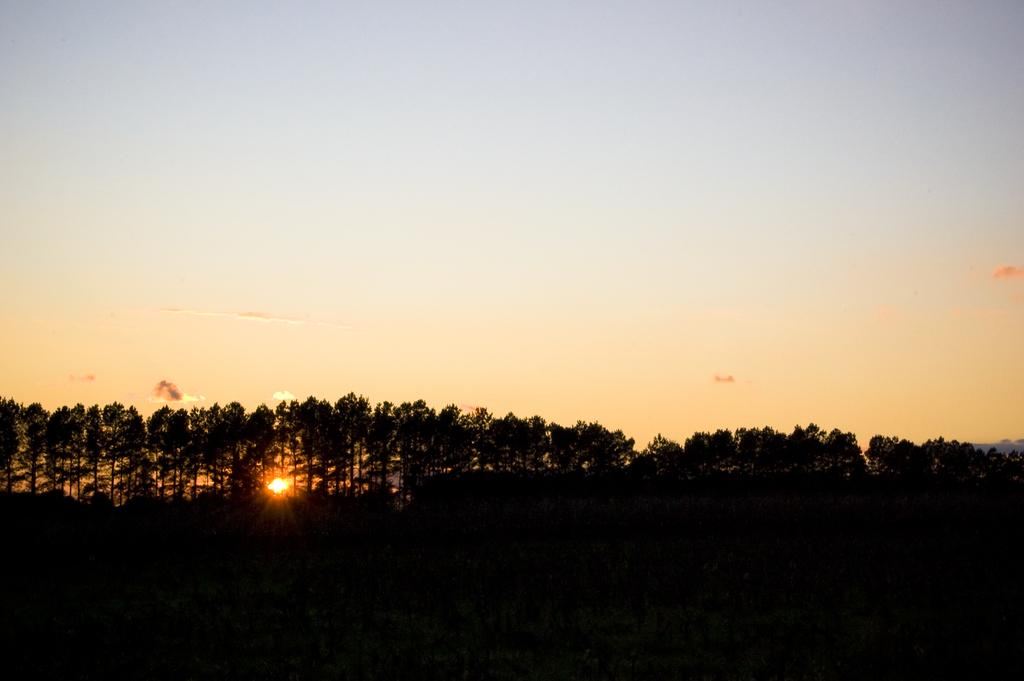What type of vegetation can be seen in the image? There are trees in the image. How would you describe the weather in the image? The sky is clear and sunny in the image, suggesting a clear and sunny day. Where is the lake located in the image? There is no lake present in the image; it only features trees and a clear, sunny sky. 